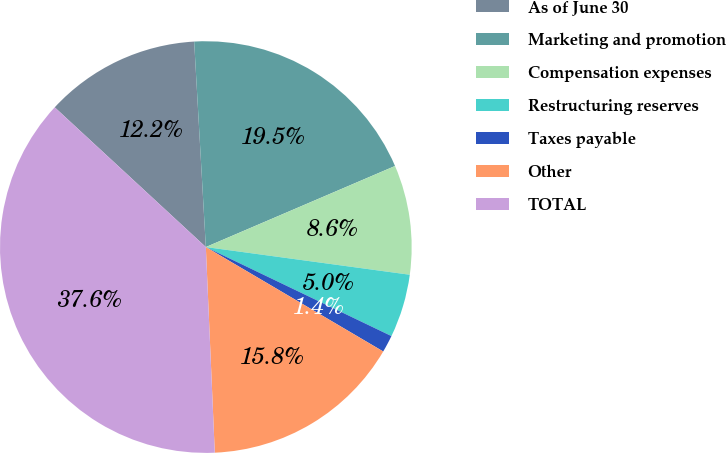Convert chart to OTSL. <chart><loc_0><loc_0><loc_500><loc_500><pie_chart><fcel>As of June 30<fcel>Marketing and promotion<fcel>Compensation expenses<fcel>Restructuring reserves<fcel>Taxes payable<fcel>Other<fcel>TOTAL<nl><fcel>12.22%<fcel>19.46%<fcel>8.59%<fcel>4.97%<fcel>1.35%<fcel>15.84%<fcel>37.57%<nl></chart> 